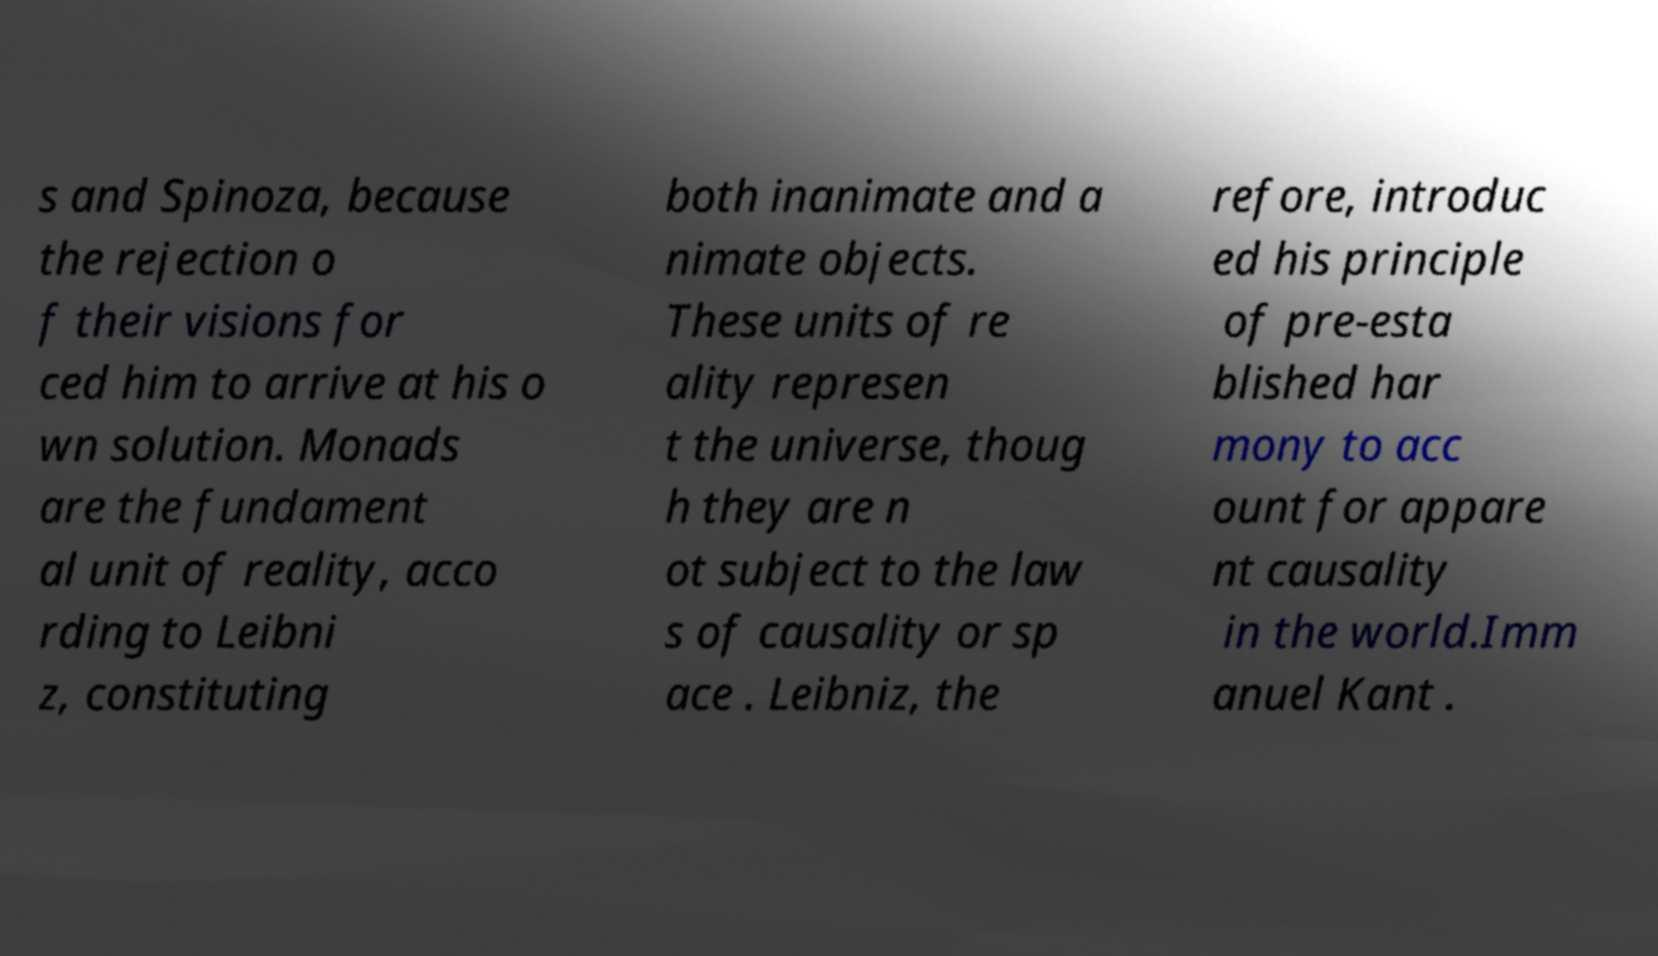There's text embedded in this image that I need extracted. Can you transcribe it verbatim? s and Spinoza, because the rejection o f their visions for ced him to arrive at his o wn solution. Monads are the fundament al unit of reality, acco rding to Leibni z, constituting both inanimate and a nimate objects. These units of re ality represen t the universe, thoug h they are n ot subject to the law s of causality or sp ace . Leibniz, the refore, introduc ed his principle of pre-esta blished har mony to acc ount for appare nt causality in the world.Imm anuel Kant . 